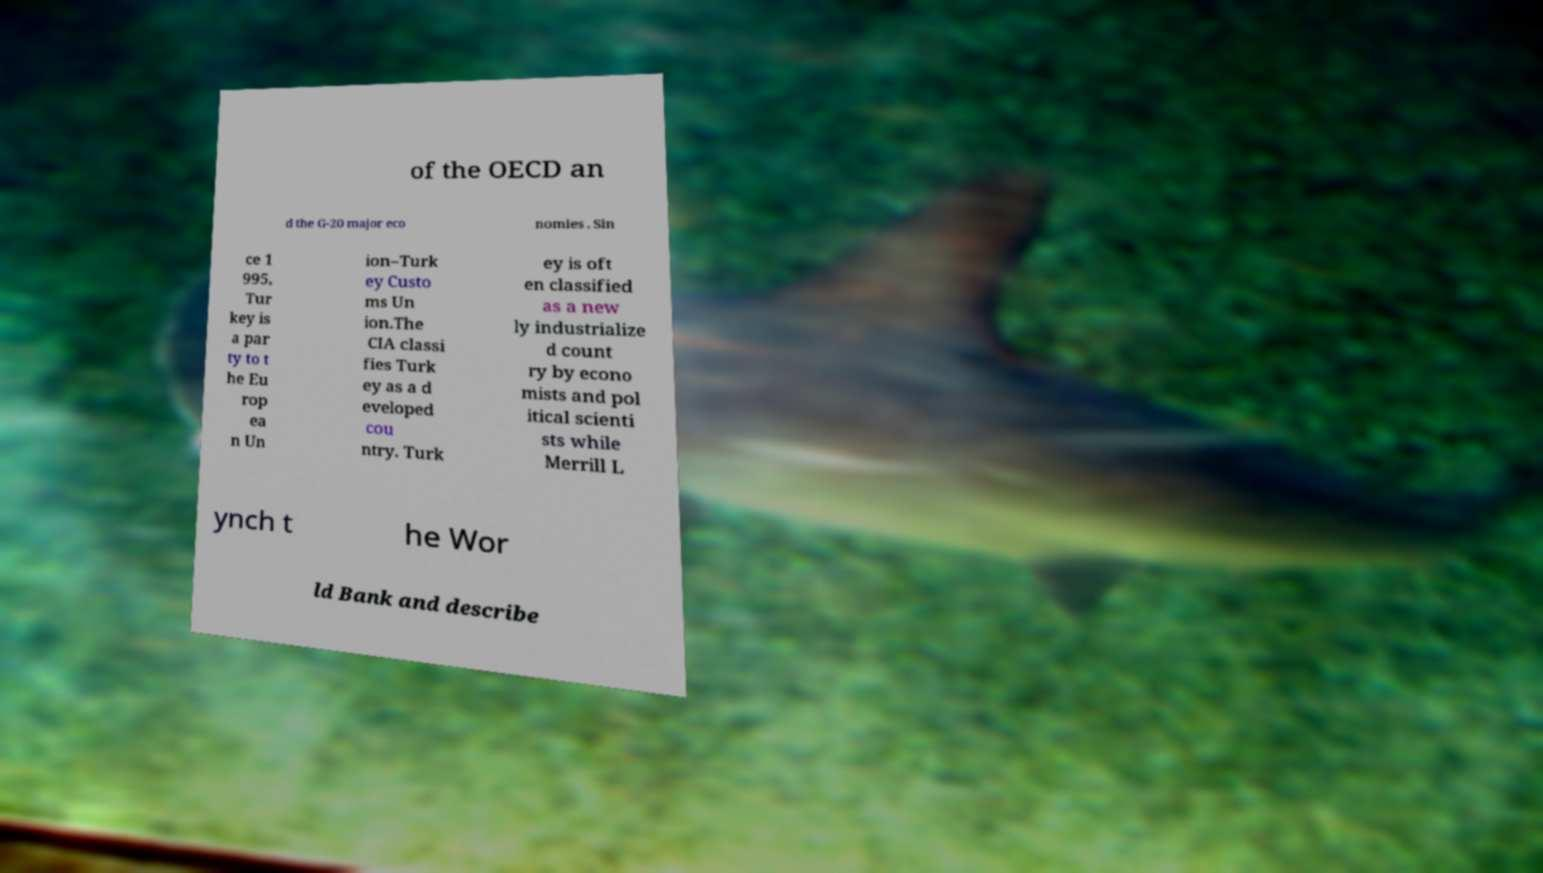What messages or text are displayed in this image? I need them in a readable, typed format. of the OECD an d the G-20 major eco nomies . Sin ce 1 995, Tur key is a par ty to t he Eu rop ea n Un ion–Turk ey Custo ms Un ion.The CIA classi fies Turk ey as a d eveloped cou ntry. Turk ey is oft en classified as a new ly industrialize d count ry by econo mists and pol itical scienti sts while Merrill L ynch t he Wor ld Bank and describe 